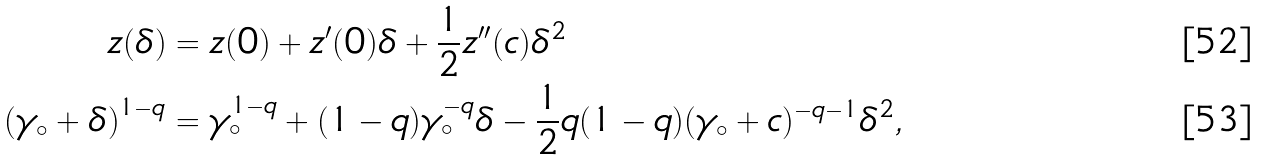<formula> <loc_0><loc_0><loc_500><loc_500>z ( \delta ) & = z ( 0 ) + z ^ { \prime } ( 0 ) \delta + \frac { 1 } { 2 } z ^ { \prime \prime } ( c ) \delta ^ { 2 } \\ \left ( \gamma _ { \circ } + \delta \right ) ^ { 1 - q } & = \gamma _ { \circ } ^ { 1 - q } + ( 1 - q ) \gamma _ { \circ } ^ { - q } \delta - \frac { 1 } { 2 } q ( 1 - q ) ( \gamma _ { \circ } + c ) ^ { - q - 1 } \delta ^ { 2 } ,</formula> 